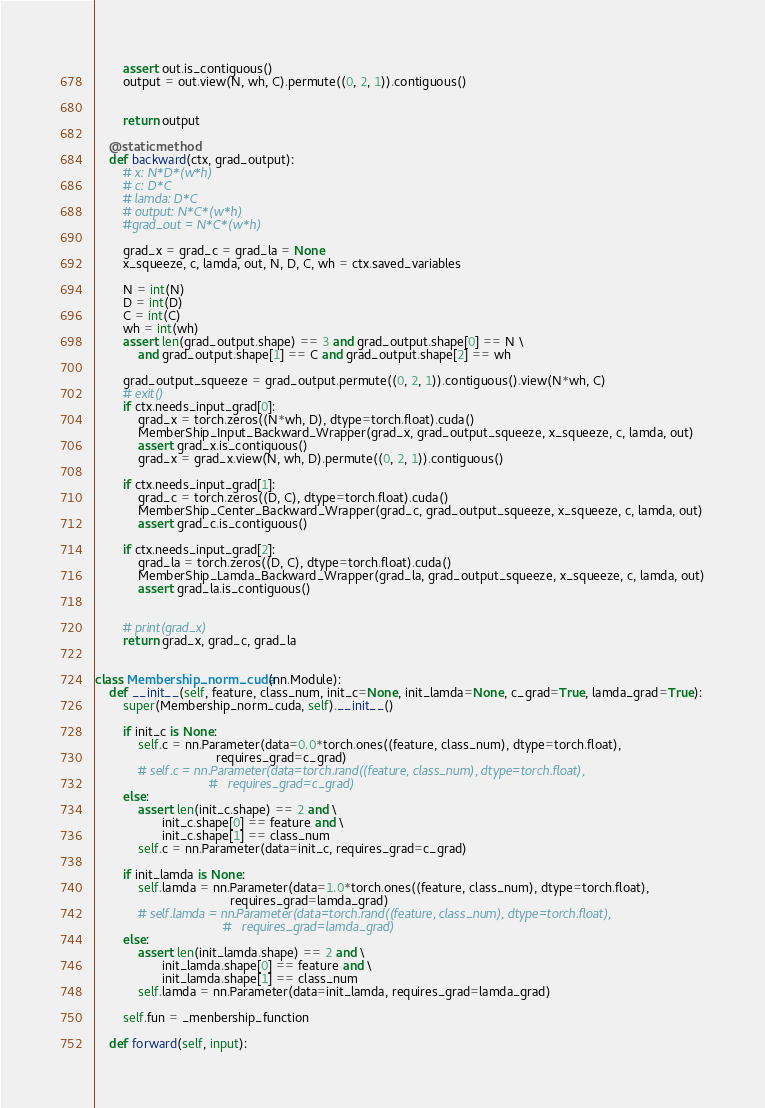<code> <loc_0><loc_0><loc_500><loc_500><_Python_>        assert out.is_contiguous()
        output = out.view(N, wh, C).permute((0, 2, 1)).contiguous()


        return output

    @staticmethod
    def backward(ctx, grad_output):
        # x: N*D*(w*h)
        # c: D*C
        # lamda: D*C
        # output: N*C*(w*h)
        #grad_out = N*C*(w*h)

        grad_x = grad_c = grad_la = None
        x_squeeze, c, lamda, out, N, D, C, wh = ctx.saved_variables

        N = int(N)
        D = int(D)
        C = int(C)
        wh = int(wh)
        assert len(grad_output.shape) == 3 and grad_output.shape[0] == N \
            and grad_output.shape[1] == C and grad_output.shape[2] == wh

        grad_output_squeeze = grad_output.permute((0, 2, 1)).contiguous().view(N*wh, C)
        # exit()
        if ctx.needs_input_grad[0]:
            grad_x = torch.zeros((N*wh, D), dtype=torch.float).cuda()
            MemberShip_Input_Backward_Wrapper(grad_x, grad_output_squeeze, x_squeeze, c, lamda, out)
            assert grad_x.is_contiguous()
            grad_x = grad_x.view(N, wh, D).permute((0, 2, 1)).contiguous()

        if ctx.needs_input_grad[1]:
            grad_c = torch.zeros((D, C), dtype=torch.float).cuda()
            MemberShip_Center_Backward_Wrapper(grad_c, grad_output_squeeze, x_squeeze, c, lamda, out)
            assert grad_c.is_contiguous()

        if ctx.needs_input_grad[2]:
            grad_la = torch.zeros((D, C), dtype=torch.float).cuda()
            MemberShip_Lamda_Backward_Wrapper(grad_la, grad_output_squeeze, x_squeeze, c, lamda, out)
            assert grad_la.is_contiguous()


        # print(grad_x)
        return grad_x, grad_c, grad_la


class Membership_norm_cuda(nn.Module):
    def __init__(self, feature, class_num, init_c=None, init_lamda=None, c_grad=True, lamda_grad=True):
        super(Membership_norm_cuda, self).__init__()

        if init_c is None:
            self.c = nn.Parameter(data=0.0*torch.ones((feature, class_num), dtype=torch.float),
                                  requires_grad=c_grad)
            # self.c = nn.Parameter(data=torch.rand((feature, class_num), dtype=torch.float),
                                #   requires_grad=c_grad)
        else:
            assert len(init_c.shape) == 2 and \
                   init_c.shape[0] == feature and \
                   init_c.shape[1] == class_num
            self.c = nn.Parameter(data=init_c, requires_grad=c_grad)

        if init_lamda is None:
            self.lamda = nn.Parameter(data=1.0*torch.ones((feature, class_num), dtype=torch.float),
                                      requires_grad=lamda_grad)
            # self.lamda = nn.Parameter(data=torch.rand((feature, class_num), dtype=torch.float),
                                    #   requires_grad=lamda_grad)
        else:
            assert len(init_lamda.shape) == 2 and \
                   init_lamda.shape[0] == feature and \
                   init_lamda.shape[1] == class_num
            self.lamda = nn.Parameter(data=init_lamda, requires_grad=lamda_grad)

        self.fun = _menbership_function

    def forward(self, input):</code> 